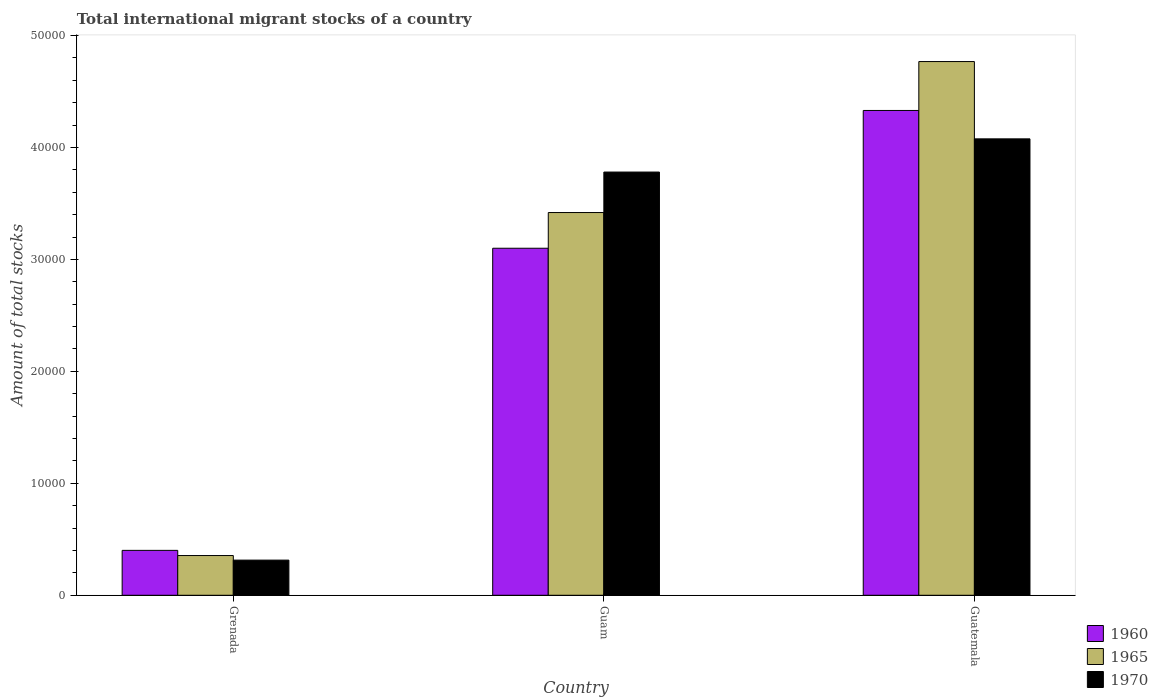How many different coloured bars are there?
Your answer should be very brief. 3. Are the number of bars per tick equal to the number of legend labels?
Your answer should be compact. Yes. Are the number of bars on each tick of the X-axis equal?
Make the answer very short. Yes. How many bars are there on the 2nd tick from the left?
Make the answer very short. 3. What is the label of the 3rd group of bars from the left?
Make the answer very short. Guatemala. What is the amount of total stocks in in 1965 in Grenada?
Your answer should be very brief. 3549. Across all countries, what is the maximum amount of total stocks in in 1960?
Provide a short and direct response. 4.33e+04. Across all countries, what is the minimum amount of total stocks in in 1970?
Offer a terse response. 3140. In which country was the amount of total stocks in in 1960 maximum?
Provide a short and direct response. Guatemala. In which country was the amount of total stocks in in 1965 minimum?
Provide a short and direct response. Grenada. What is the total amount of total stocks in in 1960 in the graph?
Ensure brevity in your answer.  7.83e+04. What is the difference between the amount of total stocks in in 1970 in Grenada and that in Guam?
Your answer should be compact. -3.47e+04. What is the difference between the amount of total stocks in in 1960 in Guatemala and the amount of total stocks in in 1970 in Guam?
Your answer should be very brief. 5503. What is the average amount of total stocks in in 1965 per country?
Offer a very short reply. 2.85e+04. What is the difference between the amount of total stocks in of/in 1970 and amount of total stocks in of/in 1960 in Grenada?
Your answer should be compact. -871. In how many countries, is the amount of total stocks in in 1965 greater than 24000?
Your answer should be very brief. 2. What is the ratio of the amount of total stocks in in 1965 in Grenada to that in Guam?
Provide a succinct answer. 0.1. Is the amount of total stocks in in 1970 in Guam less than that in Guatemala?
Offer a terse response. Yes. What is the difference between the highest and the second highest amount of total stocks in in 1965?
Offer a terse response. -4.41e+04. What is the difference between the highest and the lowest amount of total stocks in in 1965?
Give a very brief answer. 4.41e+04. In how many countries, is the amount of total stocks in in 1965 greater than the average amount of total stocks in in 1965 taken over all countries?
Your answer should be very brief. 2. Is it the case that in every country, the sum of the amount of total stocks in in 1960 and amount of total stocks in in 1970 is greater than the amount of total stocks in in 1965?
Give a very brief answer. Yes. Does the graph contain any zero values?
Keep it short and to the point. No. How are the legend labels stacked?
Offer a terse response. Vertical. What is the title of the graph?
Your response must be concise. Total international migrant stocks of a country. What is the label or title of the X-axis?
Offer a terse response. Country. What is the label or title of the Y-axis?
Offer a terse response. Amount of total stocks. What is the Amount of total stocks in 1960 in Grenada?
Ensure brevity in your answer.  4011. What is the Amount of total stocks in 1965 in Grenada?
Offer a terse response. 3549. What is the Amount of total stocks of 1970 in Grenada?
Keep it short and to the point. 3140. What is the Amount of total stocks of 1960 in Guam?
Ensure brevity in your answer.  3.10e+04. What is the Amount of total stocks in 1965 in Guam?
Provide a succinct answer. 3.42e+04. What is the Amount of total stocks in 1970 in Guam?
Your answer should be very brief. 3.78e+04. What is the Amount of total stocks in 1960 in Guatemala?
Give a very brief answer. 4.33e+04. What is the Amount of total stocks in 1965 in Guatemala?
Offer a terse response. 4.77e+04. What is the Amount of total stocks of 1970 in Guatemala?
Your answer should be very brief. 4.08e+04. Across all countries, what is the maximum Amount of total stocks in 1960?
Provide a succinct answer. 4.33e+04. Across all countries, what is the maximum Amount of total stocks of 1965?
Keep it short and to the point. 4.77e+04. Across all countries, what is the maximum Amount of total stocks of 1970?
Your answer should be compact. 4.08e+04. Across all countries, what is the minimum Amount of total stocks in 1960?
Your answer should be compact. 4011. Across all countries, what is the minimum Amount of total stocks of 1965?
Your response must be concise. 3549. Across all countries, what is the minimum Amount of total stocks in 1970?
Your answer should be compact. 3140. What is the total Amount of total stocks in 1960 in the graph?
Your answer should be compact. 7.83e+04. What is the total Amount of total stocks of 1965 in the graph?
Your answer should be very brief. 8.54e+04. What is the total Amount of total stocks of 1970 in the graph?
Offer a very short reply. 8.17e+04. What is the difference between the Amount of total stocks in 1960 in Grenada and that in Guam?
Your response must be concise. -2.70e+04. What is the difference between the Amount of total stocks of 1965 in Grenada and that in Guam?
Keep it short and to the point. -3.06e+04. What is the difference between the Amount of total stocks of 1970 in Grenada and that in Guam?
Provide a short and direct response. -3.47e+04. What is the difference between the Amount of total stocks of 1960 in Grenada and that in Guatemala?
Keep it short and to the point. -3.93e+04. What is the difference between the Amount of total stocks of 1965 in Grenada and that in Guatemala?
Your answer should be very brief. -4.41e+04. What is the difference between the Amount of total stocks of 1970 in Grenada and that in Guatemala?
Ensure brevity in your answer.  -3.76e+04. What is the difference between the Amount of total stocks of 1960 in Guam and that in Guatemala?
Provide a short and direct response. -1.23e+04. What is the difference between the Amount of total stocks in 1965 in Guam and that in Guatemala?
Your response must be concise. -1.35e+04. What is the difference between the Amount of total stocks of 1970 in Guam and that in Guatemala?
Your answer should be compact. -2966. What is the difference between the Amount of total stocks of 1960 in Grenada and the Amount of total stocks of 1965 in Guam?
Make the answer very short. -3.02e+04. What is the difference between the Amount of total stocks of 1960 in Grenada and the Amount of total stocks of 1970 in Guam?
Offer a terse response. -3.38e+04. What is the difference between the Amount of total stocks of 1965 in Grenada and the Amount of total stocks of 1970 in Guam?
Provide a short and direct response. -3.43e+04. What is the difference between the Amount of total stocks of 1960 in Grenada and the Amount of total stocks of 1965 in Guatemala?
Give a very brief answer. -4.37e+04. What is the difference between the Amount of total stocks in 1960 in Grenada and the Amount of total stocks in 1970 in Guatemala?
Keep it short and to the point. -3.68e+04. What is the difference between the Amount of total stocks of 1965 in Grenada and the Amount of total stocks of 1970 in Guatemala?
Keep it short and to the point. -3.72e+04. What is the difference between the Amount of total stocks in 1960 in Guam and the Amount of total stocks in 1965 in Guatemala?
Your response must be concise. -1.67e+04. What is the difference between the Amount of total stocks in 1960 in Guam and the Amount of total stocks in 1970 in Guatemala?
Provide a short and direct response. -9771. What is the difference between the Amount of total stocks in 1965 in Guam and the Amount of total stocks in 1970 in Guatemala?
Offer a terse response. -6582. What is the average Amount of total stocks of 1960 per country?
Your response must be concise. 2.61e+04. What is the average Amount of total stocks in 1965 per country?
Offer a terse response. 2.85e+04. What is the average Amount of total stocks of 1970 per country?
Provide a short and direct response. 2.72e+04. What is the difference between the Amount of total stocks of 1960 and Amount of total stocks of 1965 in Grenada?
Ensure brevity in your answer.  462. What is the difference between the Amount of total stocks in 1960 and Amount of total stocks in 1970 in Grenada?
Offer a terse response. 871. What is the difference between the Amount of total stocks in 1965 and Amount of total stocks in 1970 in Grenada?
Your response must be concise. 409. What is the difference between the Amount of total stocks in 1960 and Amount of total stocks in 1965 in Guam?
Provide a short and direct response. -3189. What is the difference between the Amount of total stocks in 1960 and Amount of total stocks in 1970 in Guam?
Provide a short and direct response. -6805. What is the difference between the Amount of total stocks in 1965 and Amount of total stocks in 1970 in Guam?
Ensure brevity in your answer.  -3616. What is the difference between the Amount of total stocks in 1960 and Amount of total stocks in 1965 in Guatemala?
Make the answer very short. -4368. What is the difference between the Amount of total stocks in 1960 and Amount of total stocks in 1970 in Guatemala?
Provide a succinct answer. 2537. What is the difference between the Amount of total stocks in 1965 and Amount of total stocks in 1970 in Guatemala?
Offer a very short reply. 6905. What is the ratio of the Amount of total stocks of 1960 in Grenada to that in Guam?
Provide a short and direct response. 0.13. What is the ratio of the Amount of total stocks of 1965 in Grenada to that in Guam?
Give a very brief answer. 0.1. What is the ratio of the Amount of total stocks in 1970 in Grenada to that in Guam?
Your response must be concise. 0.08. What is the ratio of the Amount of total stocks in 1960 in Grenada to that in Guatemala?
Make the answer very short. 0.09. What is the ratio of the Amount of total stocks of 1965 in Grenada to that in Guatemala?
Your response must be concise. 0.07. What is the ratio of the Amount of total stocks in 1970 in Grenada to that in Guatemala?
Offer a terse response. 0.08. What is the ratio of the Amount of total stocks of 1960 in Guam to that in Guatemala?
Offer a terse response. 0.72. What is the ratio of the Amount of total stocks of 1965 in Guam to that in Guatemala?
Offer a terse response. 0.72. What is the ratio of the Amount of total stocks of 1970 in Guam to that in Guatemala?
Your answer should be very brief. 0.93. What is the difference between the highest and the second highest Amount of total stocks of 1960?
Give a very brief answer. 1.23e+04. What is the difference between the highest and the second highest Amount of total stocks in 1965?
Provide a succinct answer. 1.35e+04. What is the difference between the highest and the second highest Amount of total stocks in 1970?
Make the answer very short. 2966. What is the difference between the highest and the lowest Amount of total stocks of 1960?
Provide a succinct answer. 3.93e+04. What is the difference between the highest and the lowest Amount of total stocks in 1965?
Keep it short and to the point. 4.41e+04. What is the difference between the highest and the lowest Amount of total stocks in 1970?
Your response must be concise. 3.76e+04. 